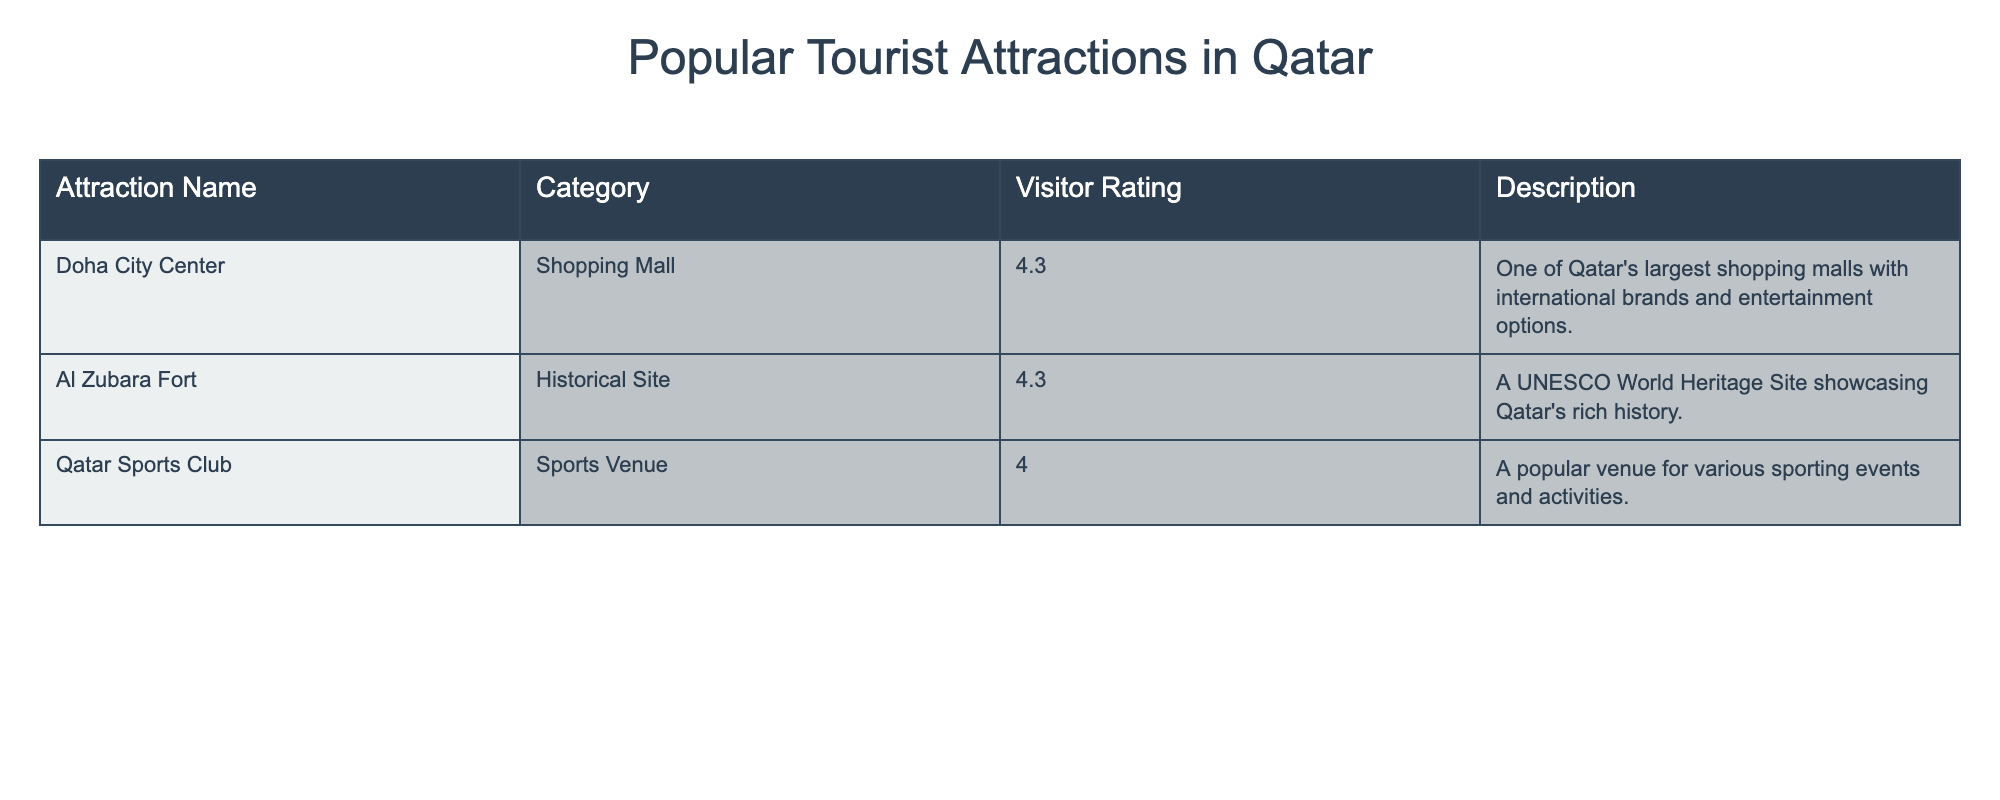What is the visitor rating of Doha City Center? The table lists the visitor rating for Doha City Center, which is explicitly mentioned in the "Visitor Rating" column. This rating is 4.3
Answer: 4.3 Which attraction has the highest visitor rating? By examining the "Visitor Rating" column, we can see that both Doha City Center and Al Zubara Fort have the highest rating of 4.3. Therefore, the recognition goes to both attractions as having the top rating
Answer: Doha City Center and Al Zubara Fort Is the Qatar Sports Club rated higher than 4.0? Checking the "Visitor Rating" for Qatar Sports Club, it shows a rating of 4.0. Since the question is asking if it is higher, we note that it is equal but not greater than 4.0
Answer: No What category does Al Zubara Fort belong to? The "Category" column indicates the type of attraction, and for Al Zubara Fort, the category is "Historical Site"
Answer: Historical Site What is the average visitor rating of the attractions listed? We sum the visitor ratings: (4.3 + 4.3 + 4.0) = 12.6, then divide by the number of attractions, which is 3. Therefore, the average is 12.6 / 3 = 4.2
Answer: 4.2 Do all attractions have a visitor rating above 4.0? Each attraction is checked against the rating threshold of 4.0. Doha City Center is rated 4.3, Al Zubara Fort is rated 4.3, and Qatar Sports Club is rated 4.0. Since Qatar Sports Club is not above 4.0 but equal, the statement is false
Answer: No Is there an attraction categorized as a shopping mall? Looking at the "Category" column, Doha City Center is listed under the "Shopping Mall" category, confirming the presence of such an attraction
Answer: Yes What is the combined visitor rating of Doha City Center and Qatar Sports Club? We take the ratings of Doha City Center (4.3) and Qatar Sports Club (4.0), and sum them: 4.3 + 4.0 = 8.3. This gives us the combined visitor rating
Answer: 8.3 Which attraction has a description mentioning "Qatar's rich history"? Reviewing the "Description" column for clues, Al Zubara Fort’s description contains the phrase "showcasing Qatar's rich history." Therefore, this attraction fits the criteria
Answer: Al Zubara Fort 